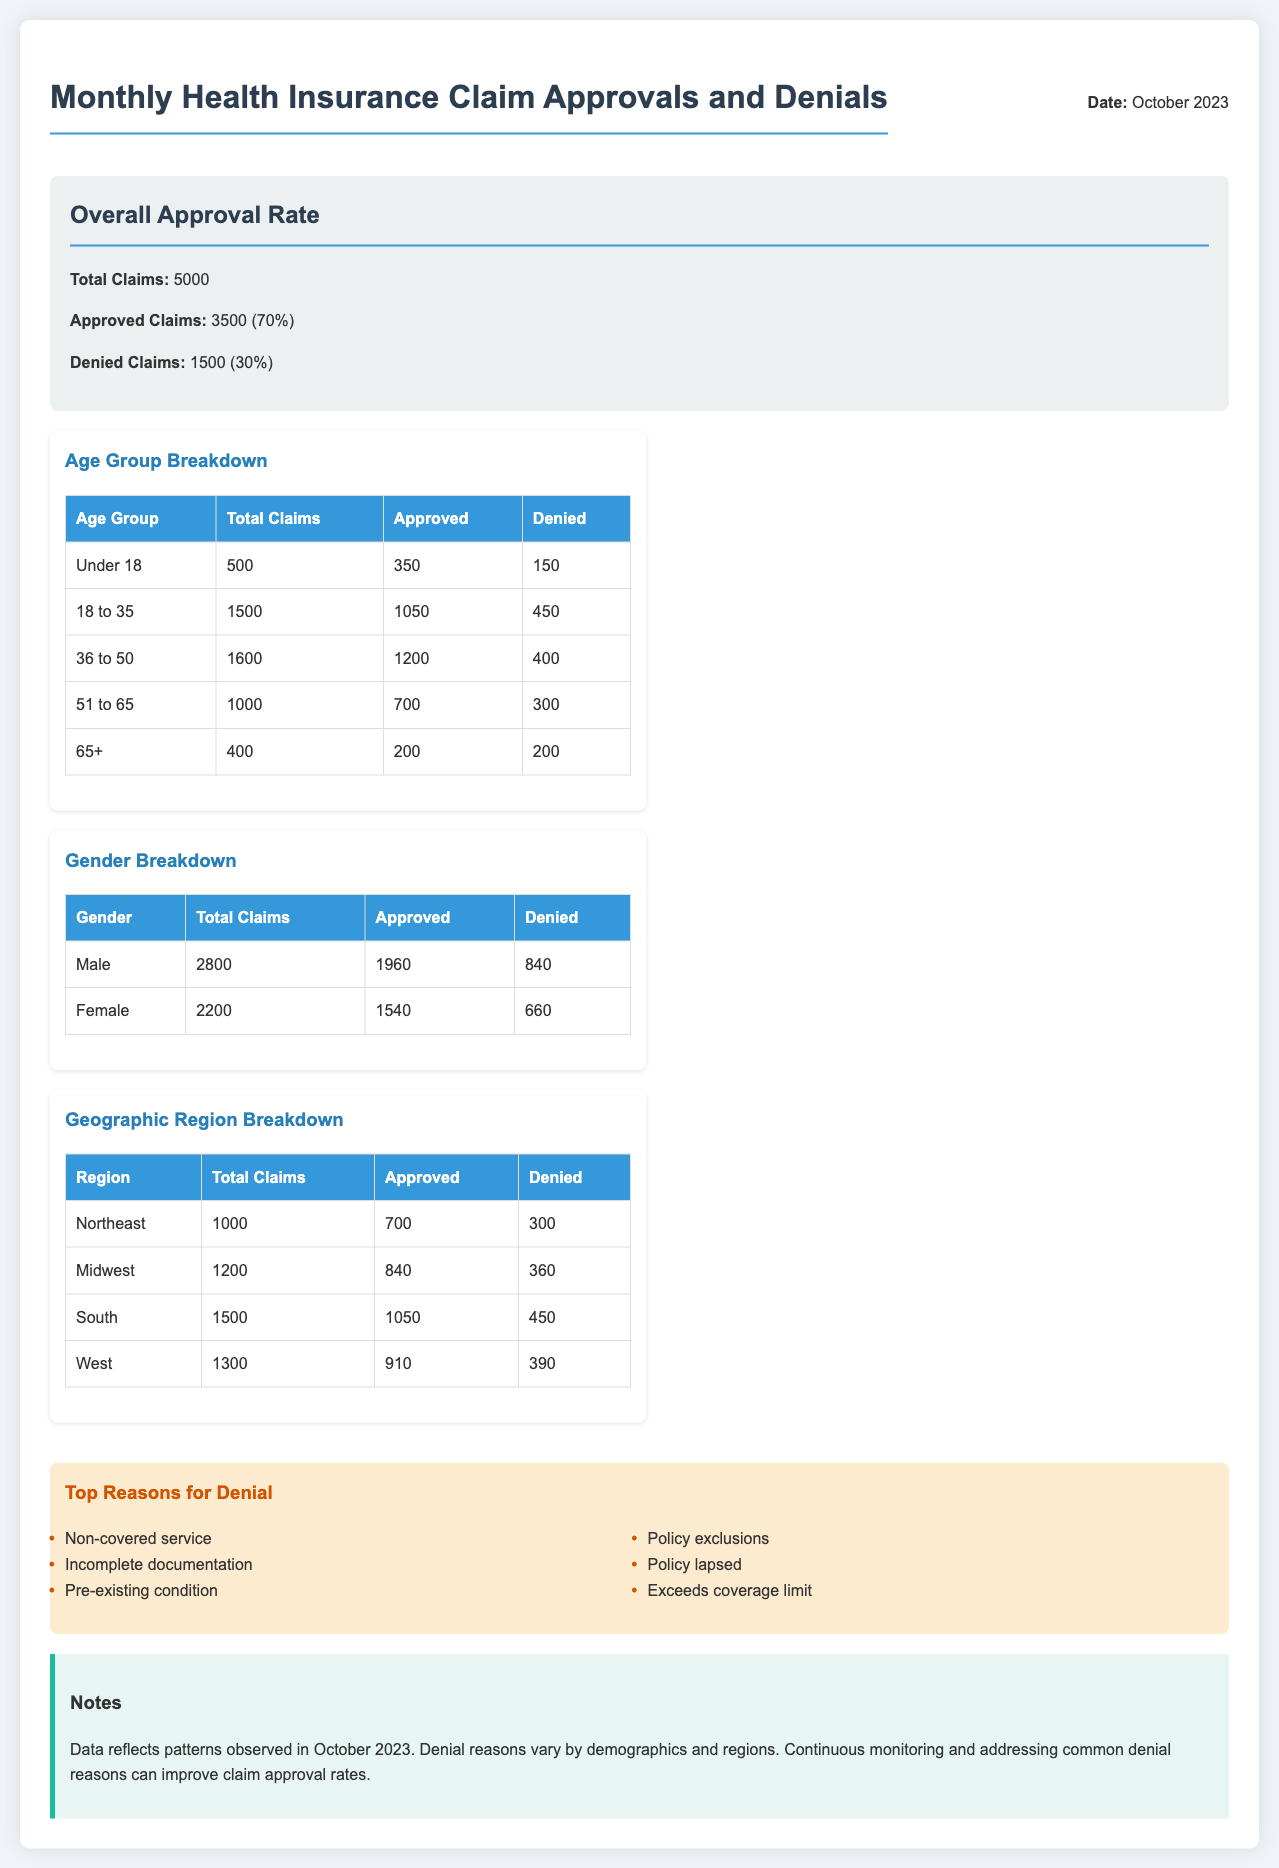What is the total number of claims? The total number of claims is stated in the approval rate section of the document, which is 5000.
Answer: 5000 How many claims were approved? The number of approved claims is also specified in the approval rate section, which is 3500.
Answer: 3500 What percentage of claims were denied? The percentage of denied claims is mentioned in the approval rate section as 30%.
Answer: 30% Which age group had the highest number of denied claims? To determine this, we compare the denied claims for each age group listed in the age group breakdown. The age group 18 to 35 has the highest number of denied claims, with 450 denials.
Answer: 18 to 35 What is the denial reason related to service coverage? The document lists various denial reasons in the denial reasons section, with "Non-covered service" being the relevant reason.
Answer: Non-covered service How many claims were denied in the Midwest region? The number of denied claims for the Midwest region is shown in the geographic region breakdown, which is 360.
Answer: 360 What is the total number of claims for females? The total claims for females can be found in the gender breakdown section, which is 2200.
Answer: 2200 What is the approval rate for the age group of 51 to 65? The approval rate for this age group can be calculated from the approved and total claims listed in the age group breakdown. The approved claims are 700 out of 1000 total claims, which is 70%.
Answer: 70% In which region were the least denied claims recorded? By reviewing the geographic region breakdown, we see that the West region has the least denied claims, with 390.
Answer: West 